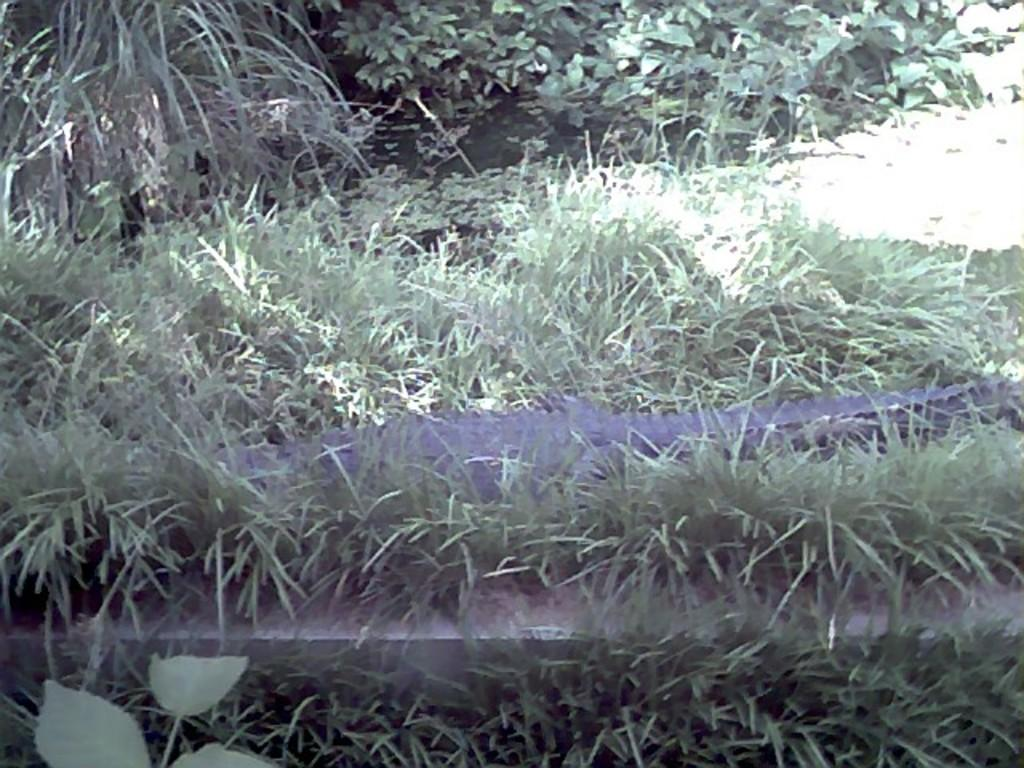What type of vegetation is present in the image? There are plants and grass in the image. Can you describe the water visible in the image? The water is visible at the top of the image. Are there any goldfish swimming in the water at the top of the image? There is no mention of goldfish or any aquatic life in the image; it only features plants, grass, and water. 